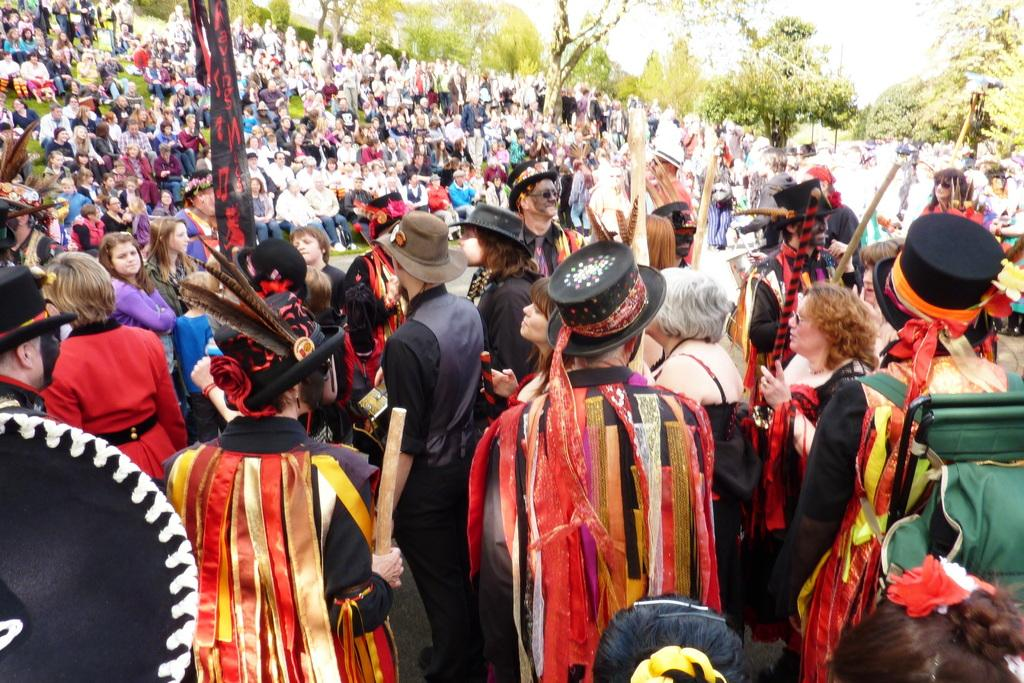How many people are in the image? There are multiple persons in the image. What are the people in the image doing? Some of the persons are sitting, while others are standing. What can be seen in the background of the image? There are trees in the background of the image. What type of scent can be detected from the tin in the image? There is no tin present in the image, so it is not possible to detect any scent from it. 